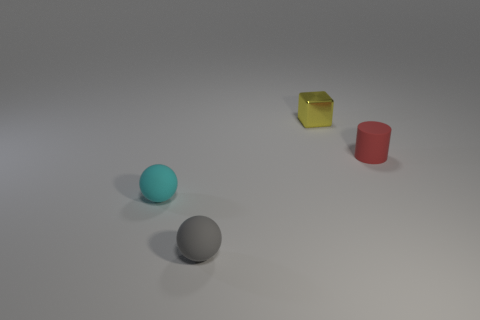What number of other things are there of the same size as the gray sphere?
Offer a terse response. 3. What is the tiny thing behind the red rubber object made of?
Provide a succinct answer. Metal. What is the shape of the tiny rubber thing that is to the right of the thing that is behind the object that is right of the yellow metallic block?
Provide a short and direct response. Cylinder. Do the cyan rubber ball and the metal object have the same size?
Your answer should be very brief. Yes. How many things are either blocks or small things that are behind the cyan ball?
Your response must be concise. 2. What number of things are tiny objects in front of the block or tiny cyan matte objects on the left side of the rubber cylinder?
Ensure brevity in your answer.  3. Are there any objects to the left of the tiny rubber cylinder?
Ensure brevity in your answer.  Yes. There is a tiny metal object to the right of the sphere that is behind the small rubber sphere that is on the right side of the tiny cyan rubber thing; what is its color?
Offer a terse response. Yellow. Does the small red matte object have the same shape as the tiny cyan thing?
Your answer should be very brief. No. What is the color of the other ball that is made of the same material as the cyan ball?
Your answer should be very brief. Gray. 